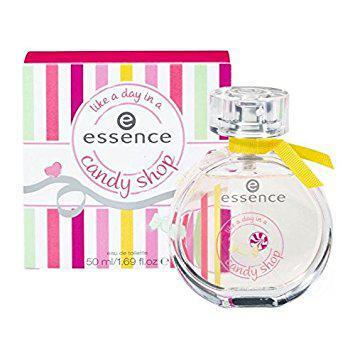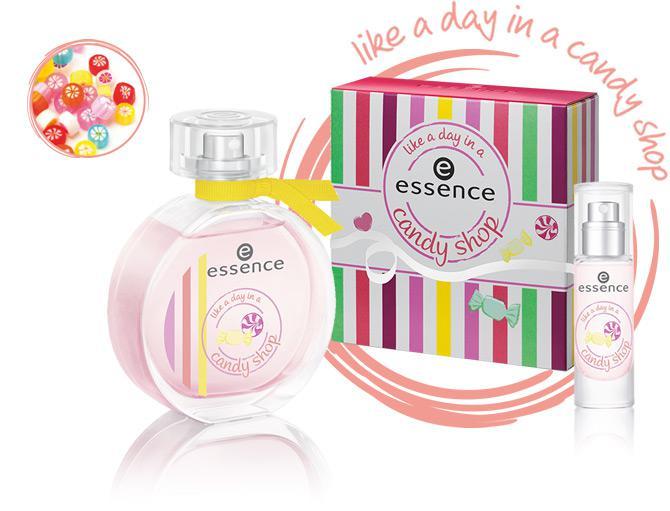The first image is the image on the left, the second image is the image on the right. Considering the images on both sides, is "Both images show a circular perfume bottle next to a candy-striped box." valid? Answer yes or no. Yes. 